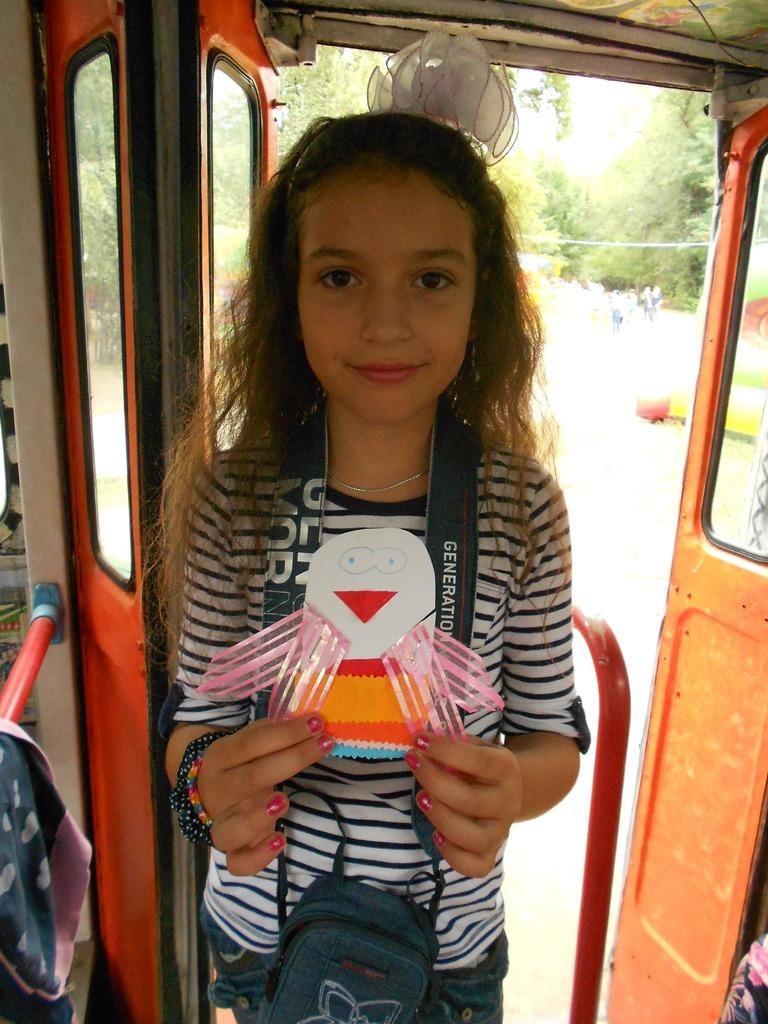Who is the main subject in the image? There is a girl in the image. What is the girl wearing? The girl is wearing a bag. Where is the girl located in the image? The girl is standing in a vehicle. What can be seen in the background of the image? There are trees and people in the background of the image. What arithmetic problem is the girl solving in the image? There is no arithmetic problem visible in the image. What type of brush is the girl using to paint the design in the image? There is no brush or design present in the image. 